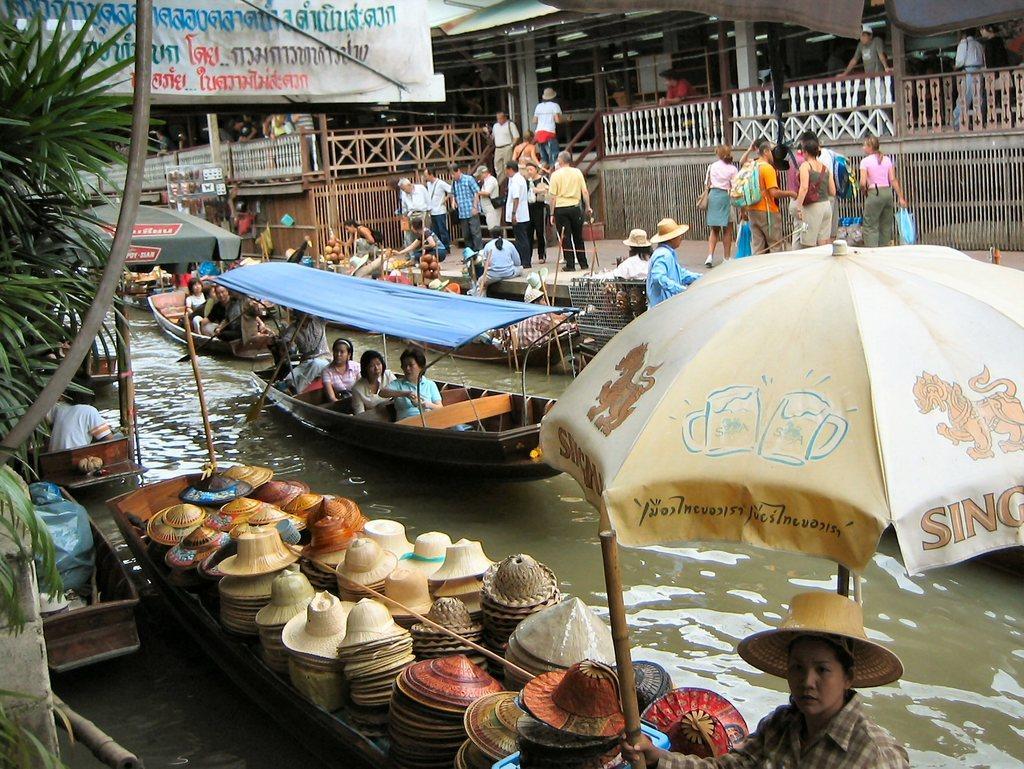Can you describe this image briefly? In this image I can see a group of people and boats in the water, umbrella hats, hats, houseplants, trees, posters, boards, fence and a group of people on the road. In the background I can see buildings, shops, wires, shed and so on. This image is taken may be during a day. 